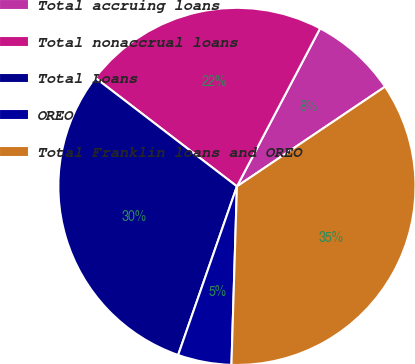Convert chart. <chart><loc_0><loc_0><loc_500><loc_500><pie_chart><fcel>Total accruing loans<fcel>Total nonaccrual loans<fcel>Total Loans<fcel>OREO<fcel>Total Franklin loans and OREO<nl><fcel>7.86%<fcel>22.3%<fcel>30.07%<fcel>4.85%<fcel>34.92%<nl></chart> 